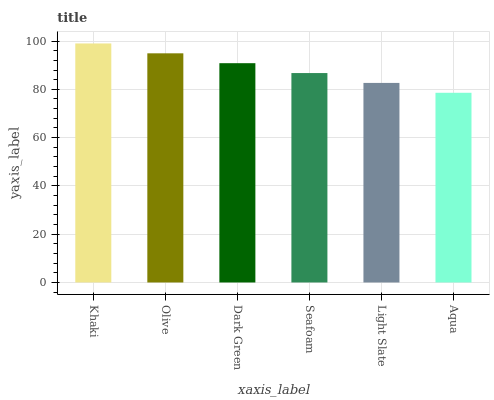Is Aqua the minimum?
Answer yes or no. Yes. Is Khaki the maximum?
Answer yes or no. Yes. Is Olive the minimum?
Answer yes or no. No. Is Olive the maximum?
Answer yes or no. No. Is Khaki greater than Olive?
Answer yes or no. Yes. Is Olive less than Khaki?
Answer yes or no. Yes. Is Olive greater than Khaki?
Answer yes or no. No. Is Khaki less than Olive?
Answer yes or no. No. Is Dark Green the high median?
Answer yes or no. Yes. Is Seafoam the low median?
Answer yes or no. Yes. Is Khaki the high median?
Answer yes or no. No. Is Olive the low median?
Answer yes or no. No. 